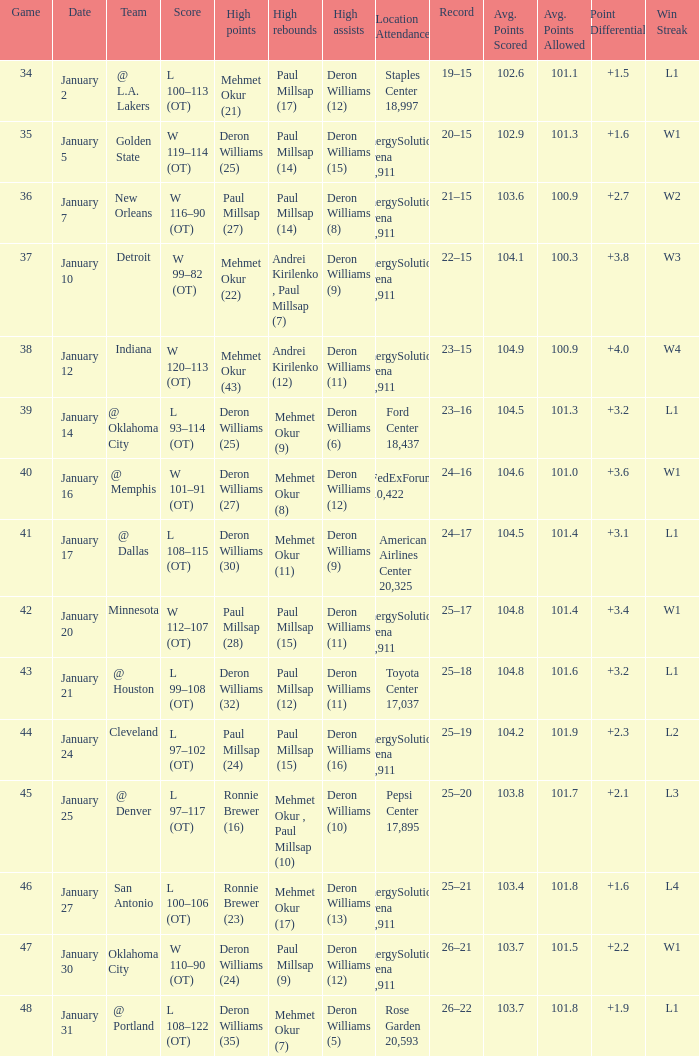What was the score of Game 48? L 108–122 (OT). Could you help me parse every detail presented in this table? {'header': ['Game', 'Date', 'Team', 'Score', 'High points', 'High rebounds', 'High assists', 'Location Attendance', 'Record', 'Avg. Points Scored', 'Avg. Points Allowed', 'Point Differential', 'Win Streak'], 'rows': [['34', 'January 2', '@ L.A. Lakers', 'L 100–113 (OT)', 'Mehmet Okur (21)', 'Paul Millsap (17)', 'Deron Williams (12)', 'Staples Center 18,997', '19–15', '102.6', '101.1', '+1.5', 'L1'], ['35', 'January 5', 'Golden State', 'W 119–114 (OT)', 'Deron Williams (25)', 'Paul Millsap (14)', 'Deron Williams (15)', 'EnergySolutions Arena 19,911', '20–15', '102.9', '101.3', '+1.6', 'W1'], ['36', 'January 7', 'New Orleans', 'W 116–90 (OT)', 'Paul Millsap (27)', 'Paul Millsap (14)', 'Deron Williams (8)', 'EnergySolutions Arena 19,911', '21–15', '103.6', '100.9', '+2.7', 'W2'], ['37', 'January 10', 'Detroit', 'W 99–82 (OT)', 'Mehmet Okur (22)', 'Andrei Kirilenko , Paul Millsap (7)', 'Deron Williams (9)', 'EnergySolutions Arena 19,911', '22–15', '104.1', '100.3', '+3.8', 'W3'], ['38', 'January 12', 'Indiana', 'W 120–113 (OT)', 'Mehmet Okur (43)', 'Andrei Kirilenko (12)', 'Deron Williams (11)', 'EnergySolutions Arena 19,911', '23–15', '104.9', '100.9', '+4.0', 'W4'], ['39', 'January 14', '@ Oklahoma City', 'L 93–114 (OT)', 'Deron Williams (25)', 'Mehmet Okur (9)', 'Deron Williams (6)', 'Ford Center 18,437', '23–16', '104.5', '101.3', '+3.2', 'L1'], ['40', 'January 16', '@ Memphis', 'W 101–91 (OT)', 'Deron Williams (27)', 'Mehmet Okur (8)', 'Deron Williams (12)', 'FedExForum 10,422', '24–16', '104.6', '101.0', '+3.6', 'W1'], ['41', 'January 17', '@ Dallas', 'L 108–115 (OT)', 'Deron Williams (30)', 'Mehmet Okur (11)', 'Deron Williams (9)', 'American Airlines Center 20,325', '24–17', '104.5', '101.4', '+3.1', 'L1'], ['42', 'January 20', 'Minnesota', 'W 112–107 (OT)', 'Paul Millsap (28)', 'Paul Millsap (15)', 'Deron Williams (11)', 'EnergySolutions Arena 19,911', '25–17', '104.8', '101.4', '+3.4', 'W1'], ['43', 'January 21', '@ Houston', 'L 99–108 (OT)', 'Deron Williams (32)', 'Paul Millsap (12)', 'Deron Williams (11)', 'Toyota Center 17,037', '25–18', '104.8', '101.6', '+3.2', 'L1'], ['44', 'January 24', 'Cleveland', 'L 97–102 (OT)', 'Paul Millsap (24)', 'Paul Millsap (15)', 'Deron Williams (16)', 'EnergySolutions Arena 19,911', '25–19', '104.2', '101.9', '+2.3', 'L2'], ['45', 'January 25', '@ Denver', 'L 97–117 (OT)', 'Ronnie Brewer (16)', 'Mehmet Okur , Paul Millsap (10)', 'Deron Williams (10)', 'Pepsi Center 17,895', '25–20', '103.8', '101.7', '+2.1', 'L3'], ['46', 'January 27', 'San Antonio', 'L 100–106 (OT)', 'Ronnie Brewer (23)', 'Mehmet Okur (17)', 'Deron Williams (13)', 'EnergySolutions Arena 19,911', '25–21', '103.4', '101.8', '+1.6', 'L4'], ['47', 'January 30', 'Oklahoma City', 'W 110–90 (OT)', 'Deron Williams (24)', 'Paul Millsap (9)', 'Deron Williams (12)', 'EnergySolutions Arena 19,911', '26–21', '103.7', '101.5', '+2.2', 'W1'], ['48', 'January 31', '@ Portland', 'L 108–122 (OT)', 'Deron Williams (35)', 'Mehmet Okur (7)', 'Deron Williams (5)', 'Rose Garden 20,593', '26–22', '103.7', '101.8', '+1.9', 'L1']]} 